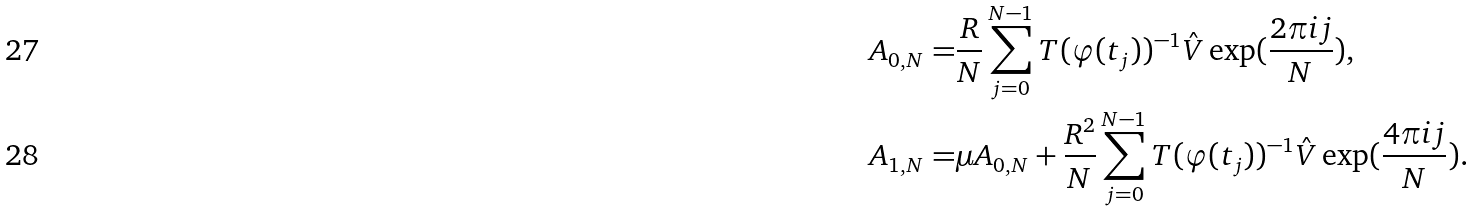<formula> <loc_0><loc_0><loc_500><loc_500>A _ { 0 , N } = & \frac { R } { N } \sum _ { j = 0 } ^ { N - 1 } T ( \varphi ( t _ { j } ) ) ^ { - 1 } \hat { V } \exp ( \frac { 2 \pi i j } { N } ) , \\ A _ { 1 , N } = & \mu A _ { 0 , N } + \frac { R ^ { 2 } } { N } \sum _ { j = 0 } ^ { N - 1 } T ( \varphi ( t _ { j } ) ) ^ { - 1 } \hat { V } \exp ( \frac { 4 \pi i j } { N } ) .</formula> 